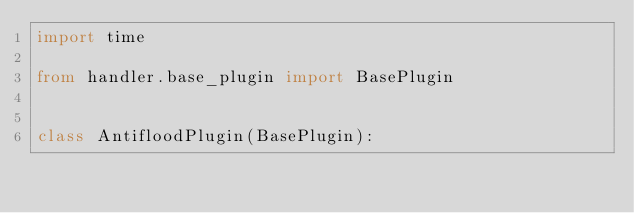<code> <loc_0><loc_0><loc_500><loc_500><_Python_>import time

from handler.base_plugin import BasePlugin


class AntifloodPlugin(BasePlugin):</code> 